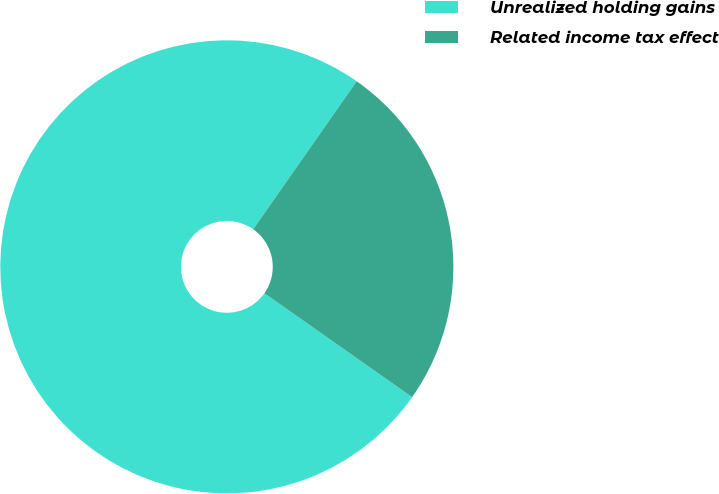<chart> <loc_0><loc_0><loc_500><loc_500><pie_chart><fcel>Unrealized holding gains<fcel>Related income tax effect<nl><fcel>74.96%<fcel>25.04%<nl></chart> 